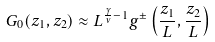Convert formula to latex. <formula><loc_0><loc_0><loc_500><loc_500>G _ { 0 } ( z _ { 1 } , z _ { 2 } ) \approx L ^ { \frac { \gamma } { \nu } - 1 } g ^ { \pm } \left ( \frac { z _ { 1 } } { L } , \frac { z _ { 2 } } { L } \right )</formula> 